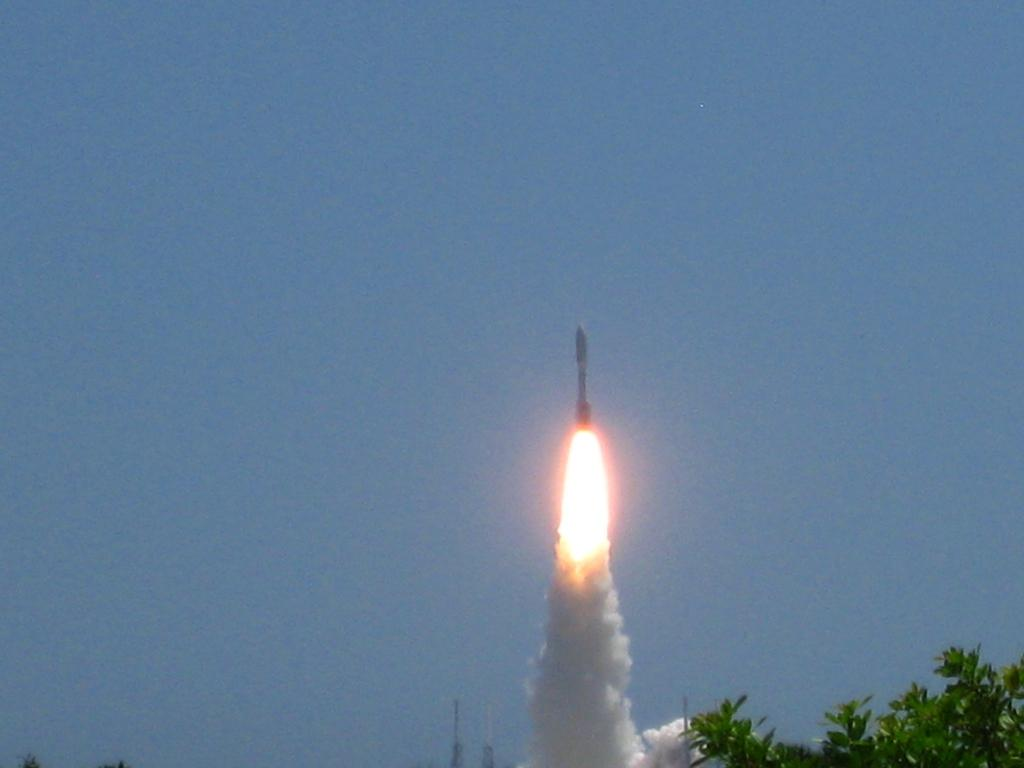What type of vegetation is at the bottom of the image? There are trees at the bottom of the image. What is the main subject in the middle of the image? There is a rocket in the middle of the image. What can be seen in the background of the image? The sky is visible in the background of the image. What song is being played by the committee in the image? There is no song or committee present in the image; it features trees, a rocket, and the sky. What type of adjustment is being made to the rocket in the image? There is no adjustment being made to the rocket in the image; it is stationary. 